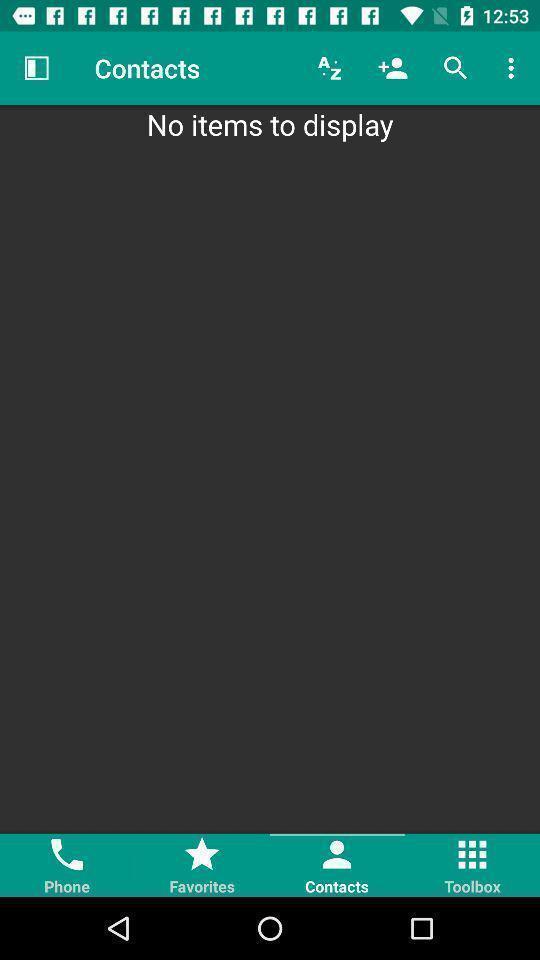Summarize the information in this screenshot. Screen shows multiple options in a call application. 